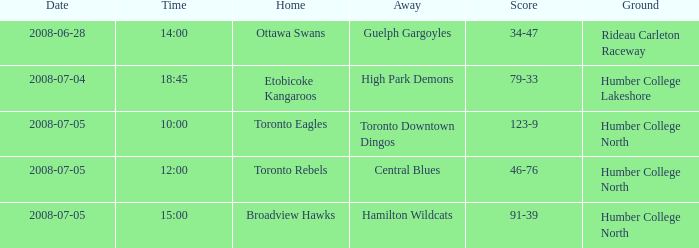What does the ground refer to in terms of a central away with blues? Humber College North. 